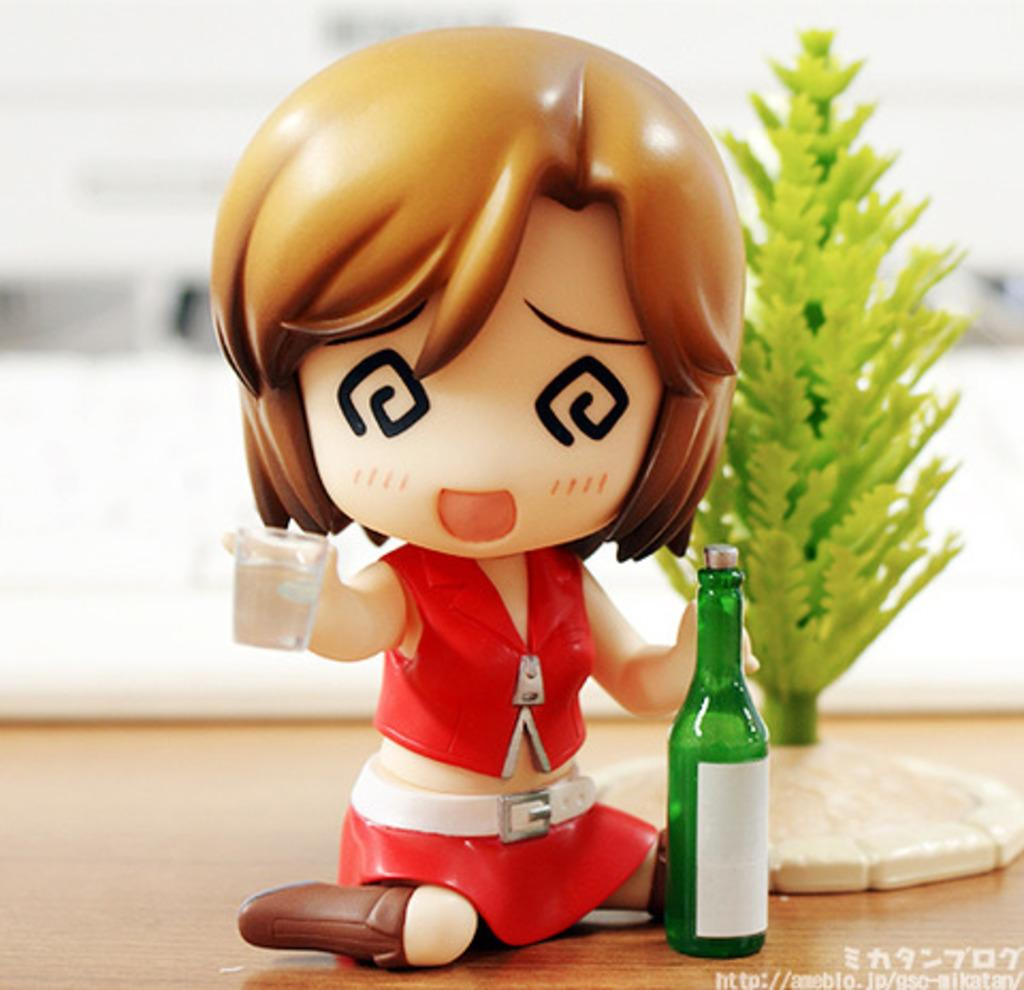What type of plant is on the table in the image? There is a plant on the table in the image. What other object can be seen on the table? There is a toy on the table in the image. What is the third object on the table? There is a bottle on the table in the image. What type of pet is visible in the image? There is no pet visible in the image; it only features a plant, a toy, and a bottle on the table. In which direction is the plant facing in the image? The direction the plant is facing cannot be determined from the image. 